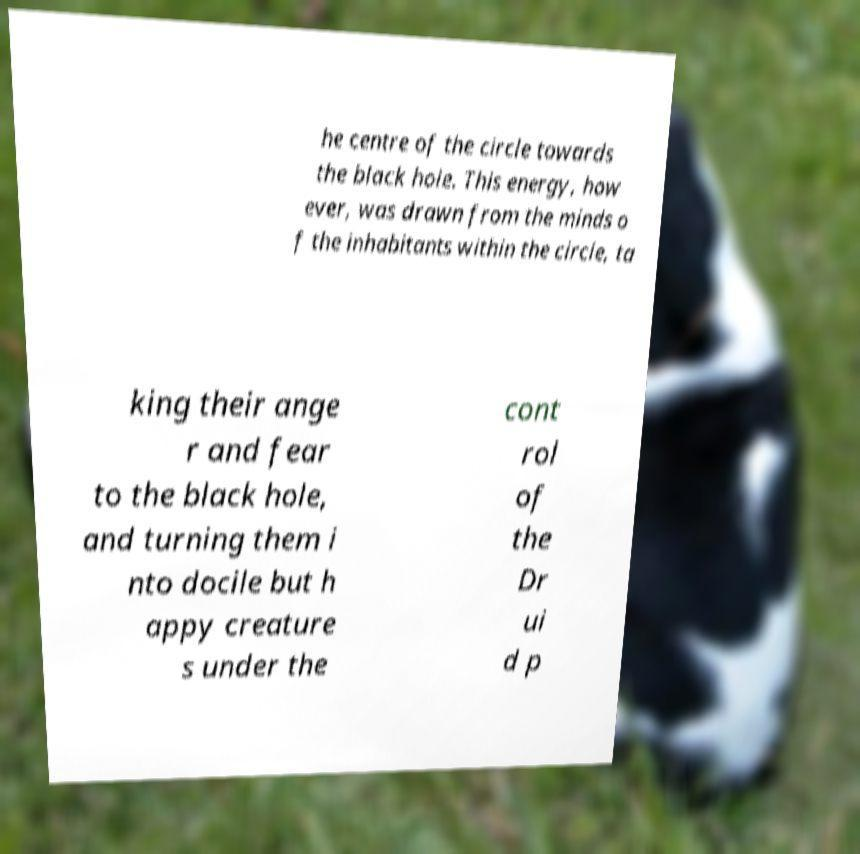Please identify and transcribe the text found in this image. he centre of the circle towards the black hole. This energy, how ever, was drawn from the minds o f the inhabitants within the circle, ta king their ange r and fear to the black hole, and turning them i nto docile but h appy creature s under the cont rol of the Dr ui d p 